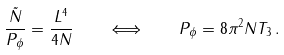<formula> <loc_0><loc_0><loc_500><loc_500>\frac { \tilde { N } } { P _ { \phi } } = \frac { L ^ { 4 } } { 4 N } \quad \Longleftrightarrow \quad P _ { \phi } = 8 \pi ^ { 2 } N T _ { 3 } \, .</formula> 